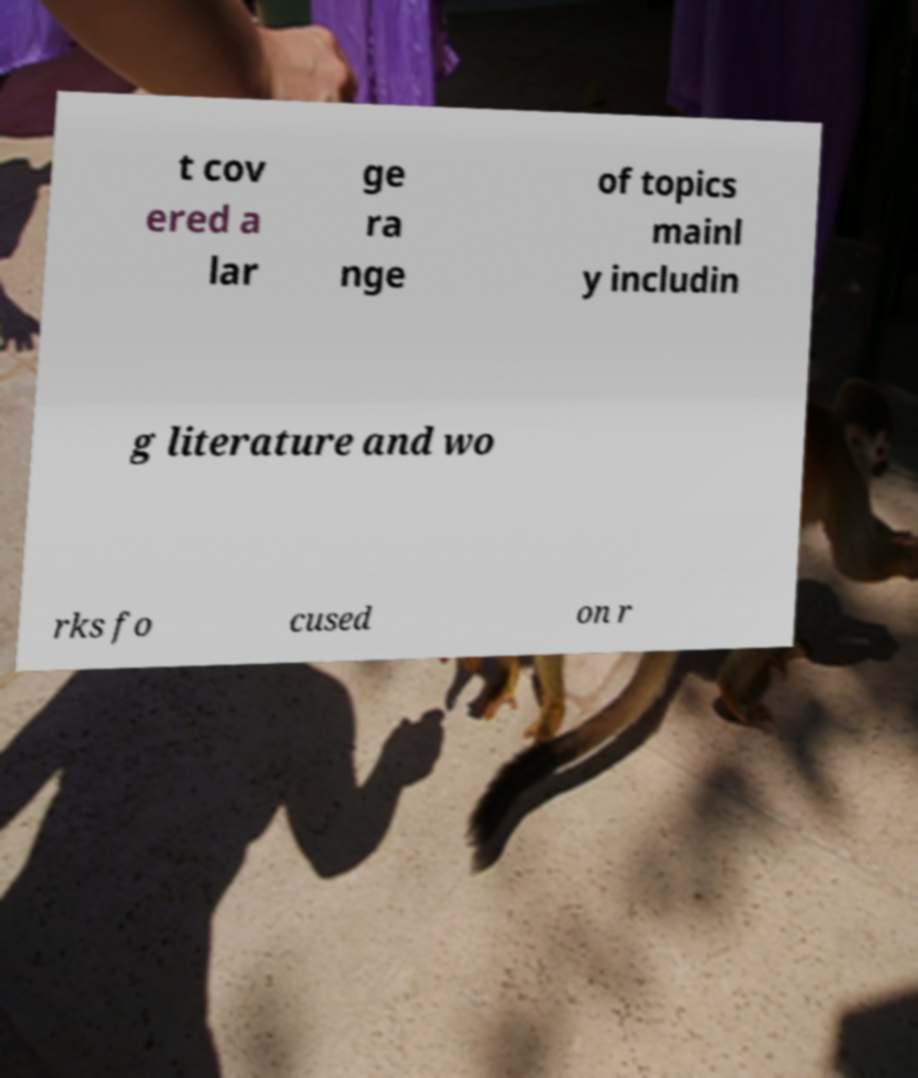I need the written content from this picture converted into text. Can you do that? t cov ered a lar ge ra nge of topics mainl y includin g literature and wo rks fo cused on r 